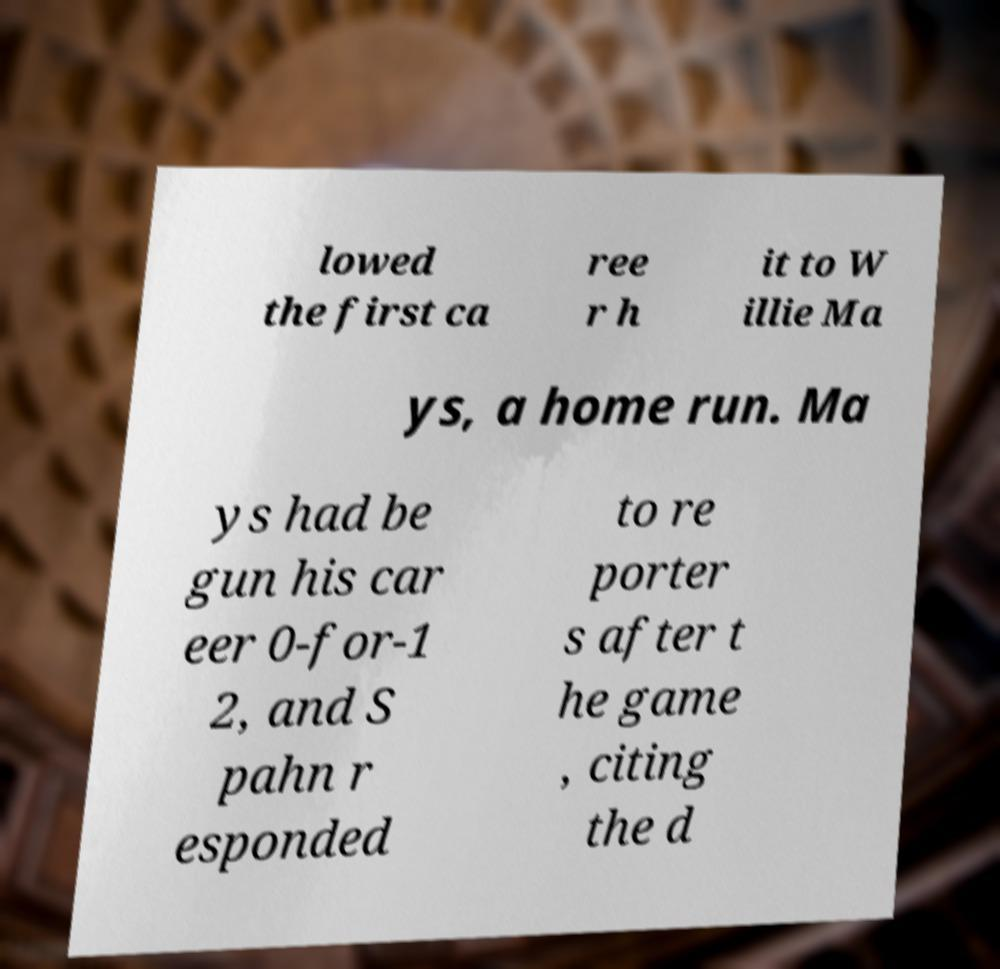There's text embedded in this image that I need extracted. Can you transcribe it verbatim? lowed the first ca ree r h it to W illie Ma ys, a home run. Ma ys had be gun his car eer 0-for-1 2, and S pahn r esponded to re porter s after t he game , citing the d 